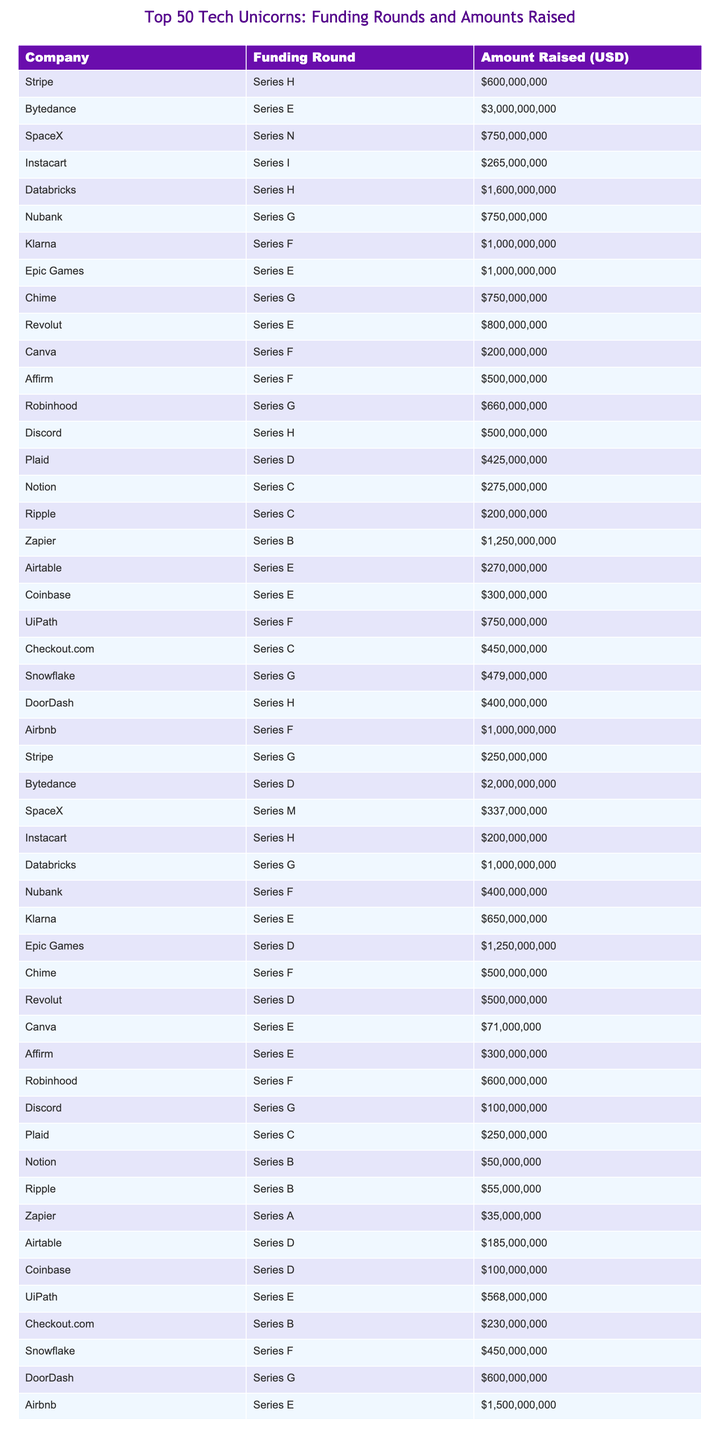What is the total amount raised by Stripe in all funding rounds? Stripe has two entries in the table: Series H with $600,000,000 and Series G with $250,000,000. Adding these amounts together gives a total of $600,000,000 + $250,000,000 = $850,000,000.
Answer: $850,000,000 Which company raised the most amount of funding in a single round? Bytedance has the highest single funding amount listed, which is $3,000,000,000 from Series E.
Answer: Bytedance How many companies raised more than $1 billion in total across all their funding rounds? Reviewing each company's total funding amounts, the companies that exceed $1 billion are Bytedance, Databricks, and Epic Games. Bytedance has two rounds totaling $2,300,000,000 and Databricks $1,600,000,000, totaling three companies.
Answer: 3 Is there a company that raised money in both Series E and Series G rounds? Based on the table, Chime raised funds in both Series E ($750,000,000) and Series G ($660,000,000) rounds.
Answer: Yes What is the average amount raised in Series D rounds across all companies? The Series D amounts raised are $425,000,000 (Plaid), $200,000,000 (Coinbase), $185,000,000 (Airtable), and $2,000,000,000 (Bytedance). Summing these amounts: $425,000,000 + $200,000,000 + $185,000,000 + $2,000,000,000 = $2,810,000,000. There are 4 entries, so the average is $2,810,000,000 / 4 = $702,500,000.
Answer: $702,500,000 Which company had the lowest amount raised in any funding round? The company that raised the least is Zapier, with an amount of $35,000,000 in Series A.
Answer: Zapier How does the total amount raised by Klarna compare to that raised by Robinhood? Klarna's rounds total $1,600,000,000 ($1,000,000,000 in Series F and $650,000,000 in Series E), while Robinhood's rounds total $1,260,000,000 ($660,000,000 in Series G and $600,000,000 in Series F). Klarna raised more than Robinhood.
Answer: Klarna raised more How many companies raised funding in both Series F and Series G rounds? Upon examining the entries, Chime, Stripe, UiPath, Robinhood, and Discord raised in both Series F and Series G. This totals 5 companies that had funding in both rounds.
Answer: 5 What is the total amount raised by all Series H rounds combined? Adding all Series H rounds: Stripe ($600,000,000), SpaceX ($750,000,000), Instacart ($200,000,000), Chime ($750,000,000), Discord ($500,000,000), and DoorDash ($400,000,000) gives $600,000,000 + $750,000,000 + $200,000,000 + $750,000,000 + $500,000,000 + $400,000,000 = $3,200,000,000.
Answer: $3,200,000,000 Which two companies have the closest amounts raised? Looking at the amounts raised, Notion with $275,000,000 and Airtable with $185,000,000 have the closest amounts, differing by $90,000,000.
Answer: Notion and Airtable Is there any company that raised the same amount in different funding rounds? No, upon reviewing the table, there are no companies that have the same amount raised in different funding rounds.
Answer: No 